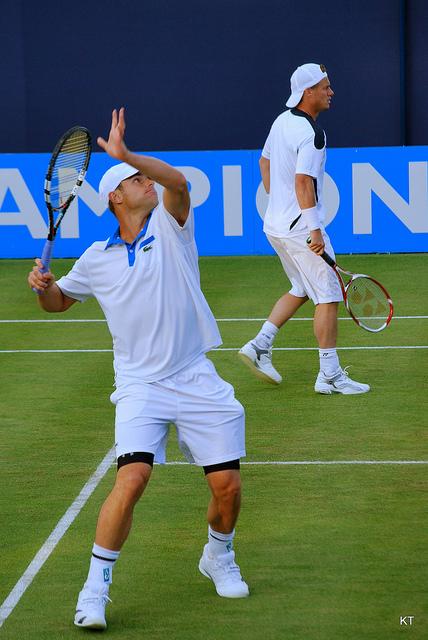Are they wearing bright colors?
Give a very brief answer. Yes. Which game is been played?
Quick response, please. Tennis. What color are the men wearing?
Short answer required. White. 